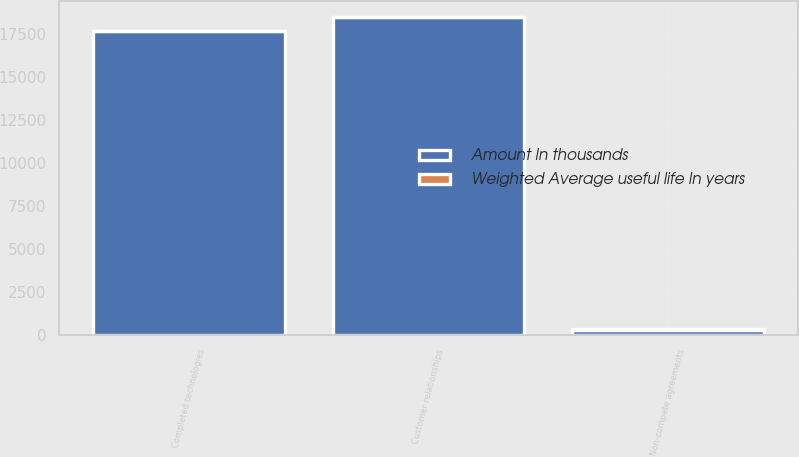<chart> <loc_0><loc_0><loc_500><loc_500><stacked_bar_chart><ecel><fcel>Completed technologies<fcel>Customer relationships<fcel>Non-compete agreements<nl><fcel>Amount In thousands<fcel>17700<fcel>18500<fcel>300<nl><fcel>Weighted Average useful life In years<fcel>4.4<fcel>5.9<fcel>2.5<nl></chart> 